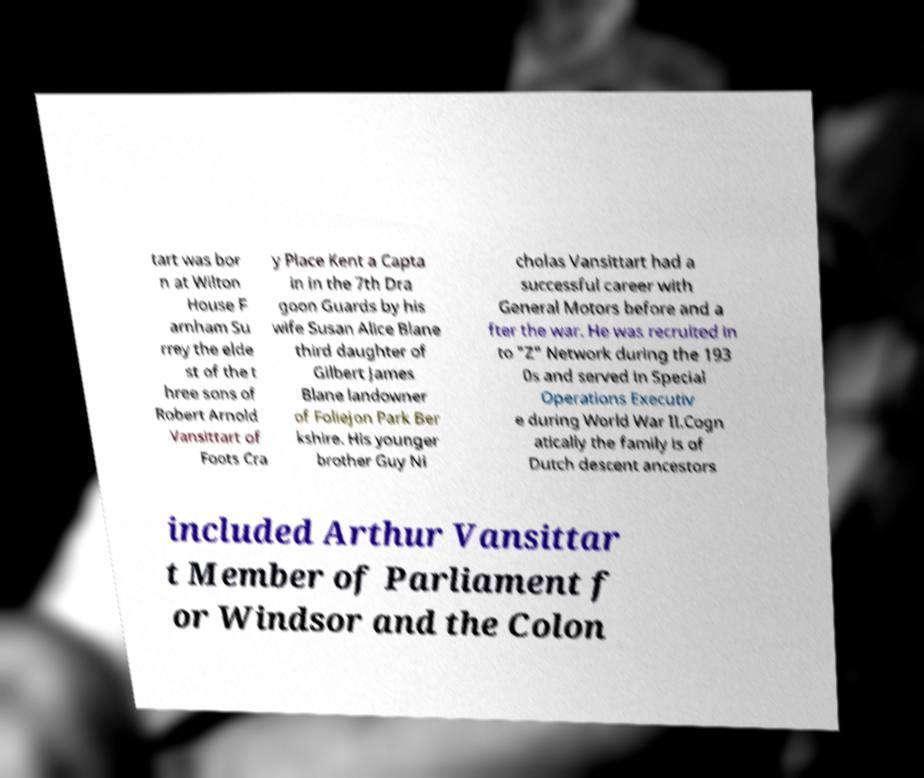Could you extract and type out the text from this image? tart was bor n at Wilton House F arnham Su rrey the elde st of the t hree sons of Robert Arnold Vansittart of Foots Cra y Place Kent a Capta in in the 7th Dra goon Guards by his wife Susan Alice Blane third daughter of Gilbert James Blane landowner of Foliejon Park Ber kshire. His younger brother Guy Ni cholas Vansittart had a successful career with General Motors before and a fter the war. He was recruited in to "Z" Network during the 193 0s and served in Special Operations Executiv e during World War II.Cogn atically the family is of Dutch descent ancestors included Arthur Vansittar t Member of Parliament f or Windsor and the Colon 